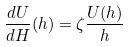<formula> <loc_0><loc_0><loc_500><loc_500>\frac { d U } { d H } ( h ) = \zeta \frac { U ( h ) } { h }</formula> 